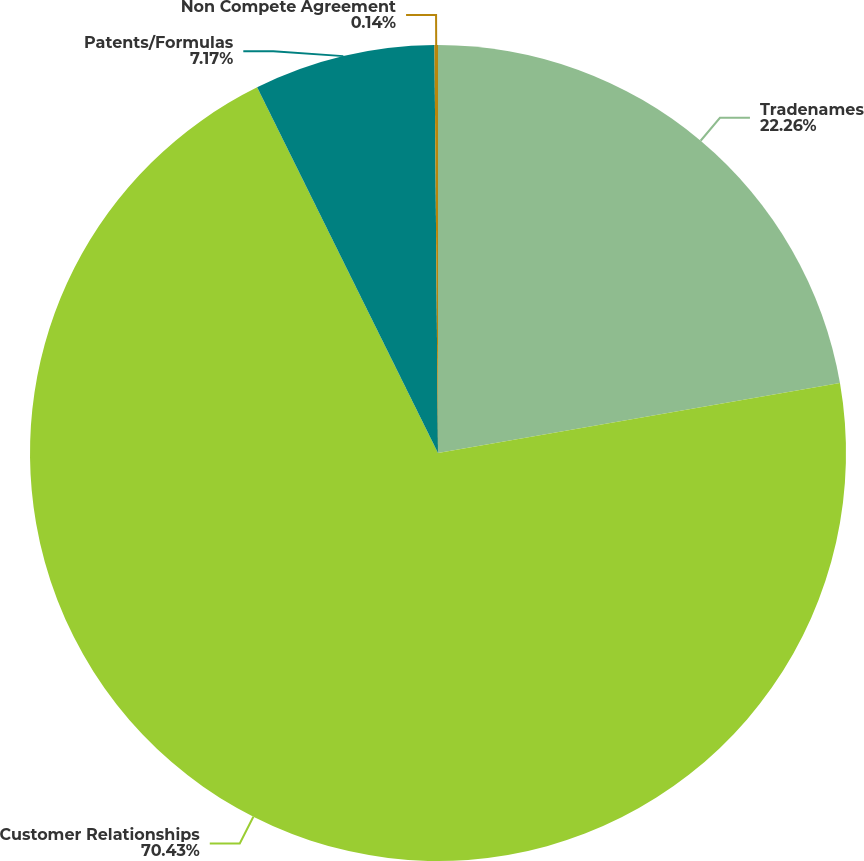Convert chart to OTSL. <chart><loc_0><loc_0><loc_500><loc_500><pie_chart><fcel>Tradenames<fcel>Customer Relationships<fcel>Patents/Formulas<fcel>Non Compete Agreement<nl><fcel>22.26%<fcel>70.43%<fcel>7.17%<fcel>0.14%<nl></chart> 